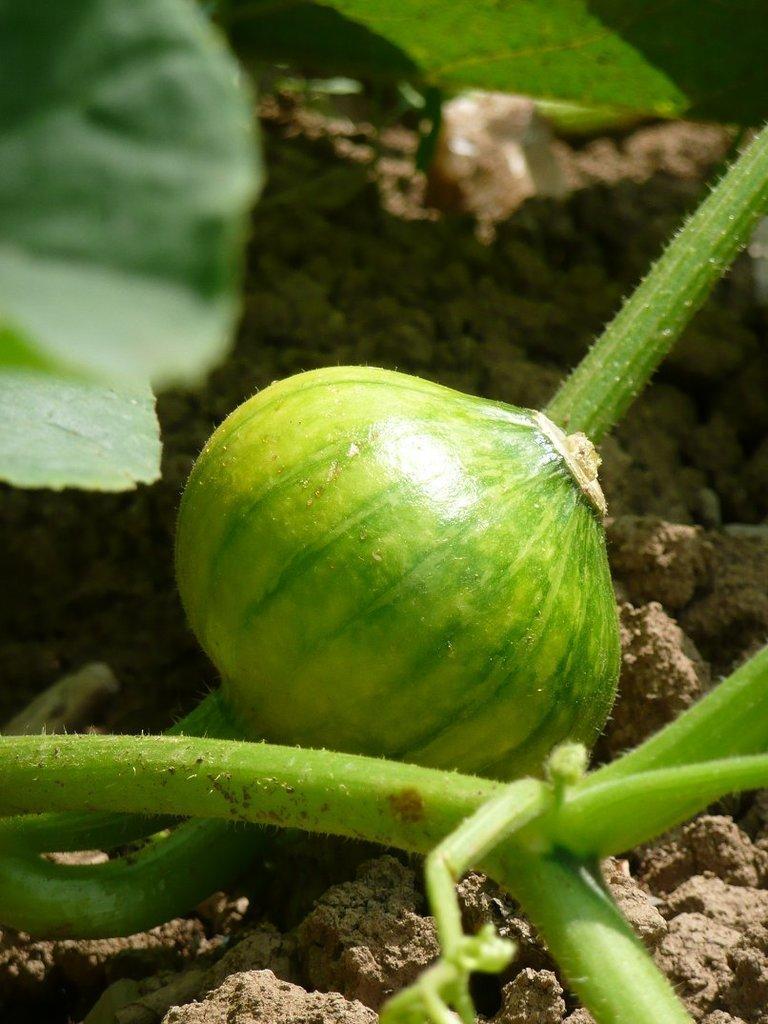How would you summarize this image in a sentence or two? In this image I can see a vegetable which is in green color to a stem. At the bottom of the image I can see mud. On the top of the image there are two leave visible. 